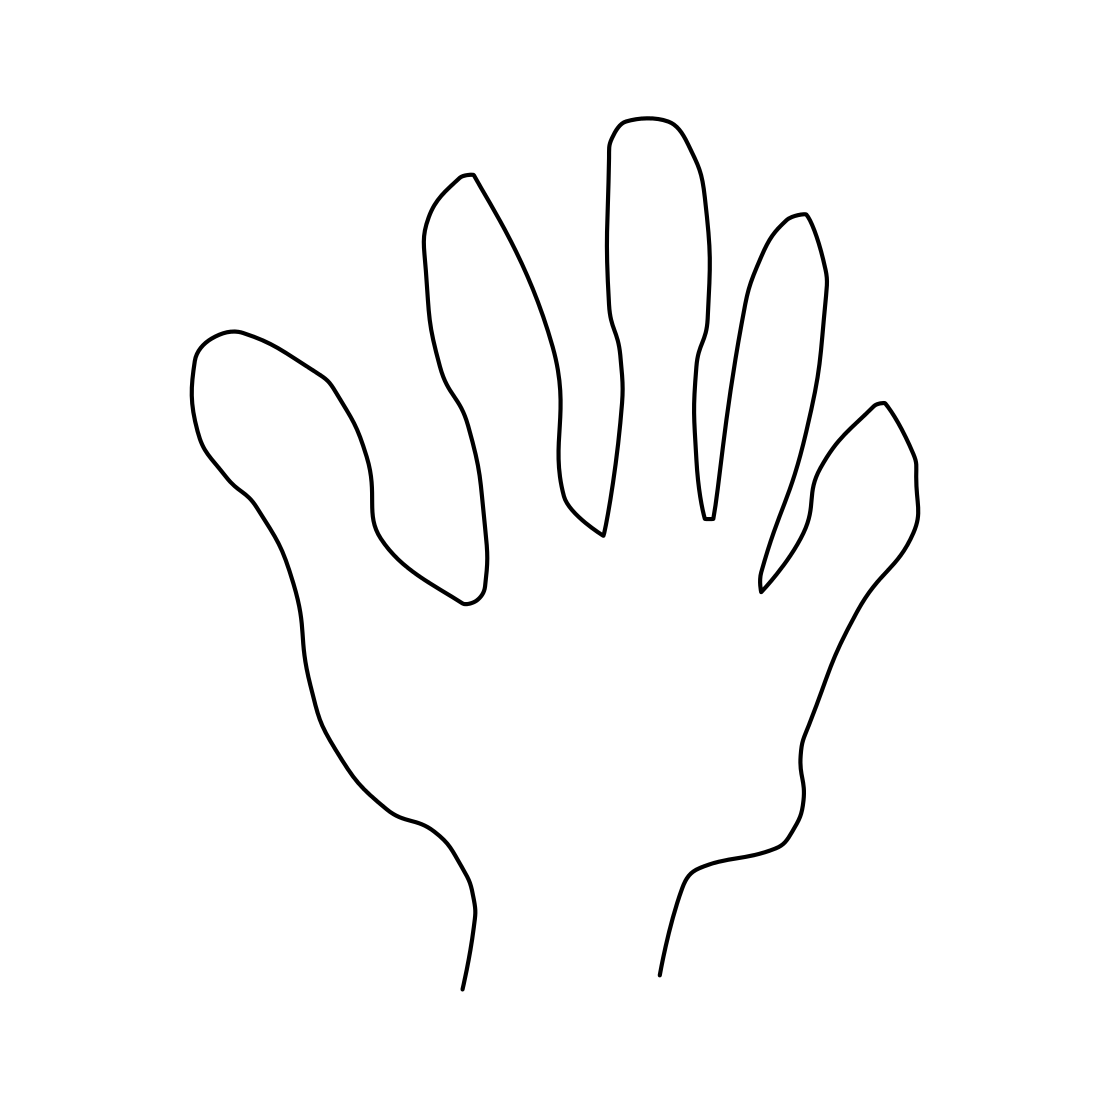Is this a frog in the image? The image depicts a simple line drawing of a human hand, not a frog. The illustration shows the outline of a hand with separated fingers, which can be identified by the thumb and other four fingers, distinctive traits absent in a frog's anatomy. 